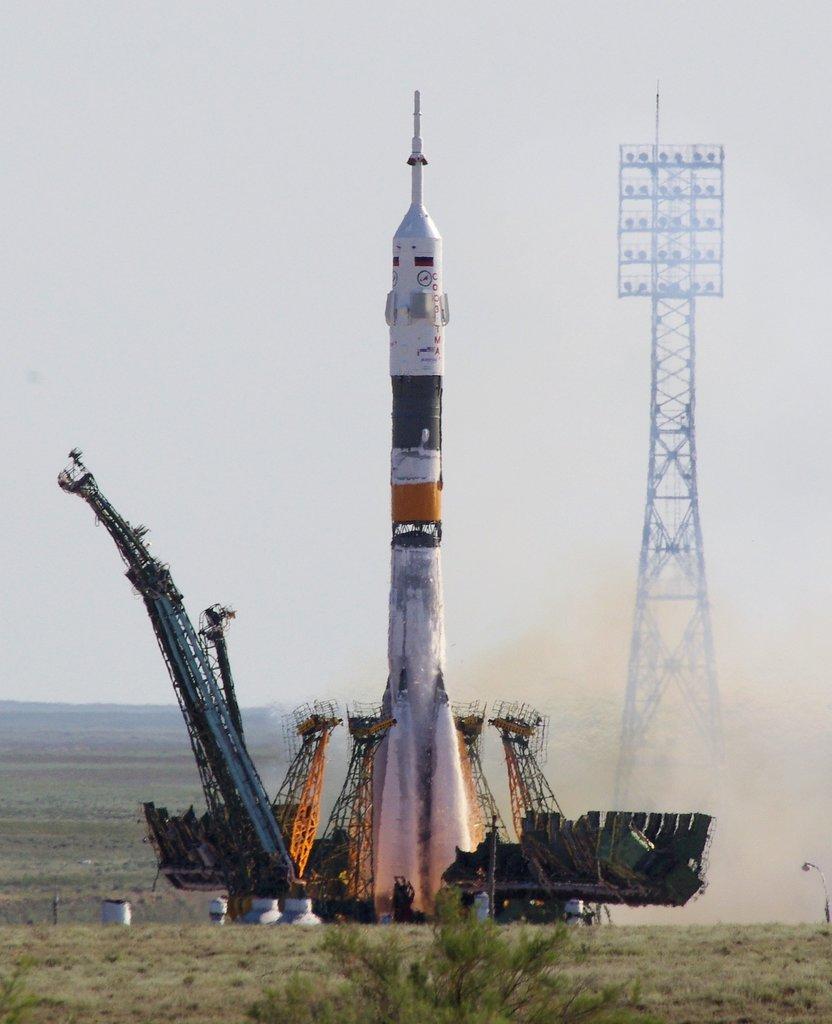Could you give a brief overview of what you see in this image? In this picture we can see a rocket here, we can see a launch pad here, at the bottom there is some grass, we can see a tower here, in the background there is the sky. 